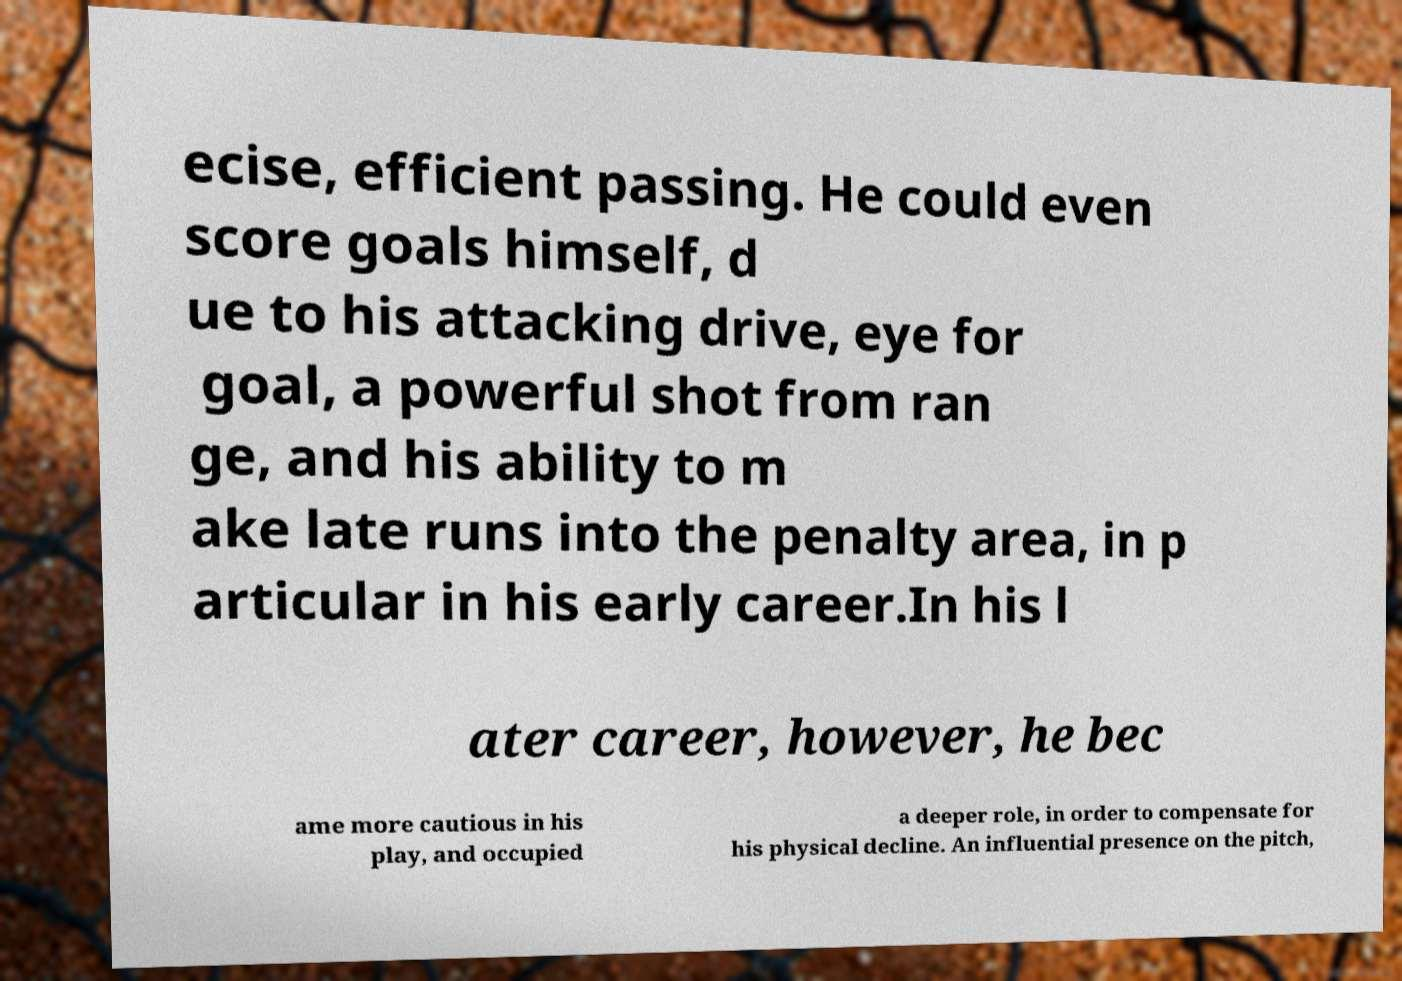Please read and relay the text visible in this image. What does it say? ecise, efficient passing. He could even score goals himself, d ue to his attacking drive, eye for goal, a powerful shot from ran ge, and his ability to m ake late runs into the penalty area, in p articular in his early career.In his l ater career, however, he bec ame more cautious in his play, and occupied a deeper role, in order to compensate for his physical decline. An influential presence on the pitch, 